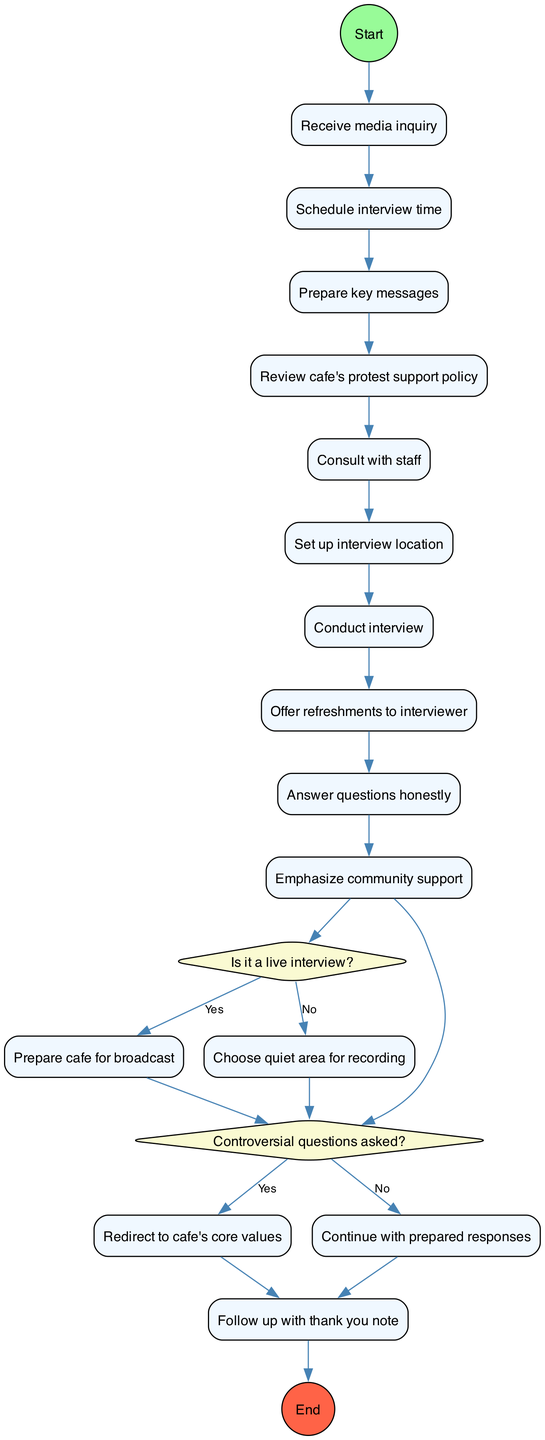What is the start node of the activity diagram? The start node is labeled with "Start" and is the initiating point of the flow in the diagram. It connects to the first activity, which is "Receive media inquiry."
Answer: Start How many activities are there in the diagram? There are a total of 9 activities listed in the diagram, starting from "Schedule interview time" to "Emphasize community support."
Answer: 9 What is the first activity after receiving a media inquiry? The first activity that follows the "Receive media inquiry" node is "Schedule interview time," indicating the first step in the process.
Answer: Schedule interview time What action is taken if the interview is live? If the interview is live, the next action is to "Prepare cafe for broadcast," which suggests adjustments to accommodate a live setting.
Answer: Prepare cafe for broadcast What happens if controversial questions are asked during the interview? When controversial questions are asked, the flow redirects to "Redirect to cafe's core values," ensuring the focus remains on the cafe's mission and values.
Answer: Redirect to cafe's core values How does the diagram end? The diagram concludes with a node labeled "Follow up with thank you note," which signifies the closure of the inquiry handling process.
Answer: Follow up with thank you note What decision follows the last activity? The last activity leads to a decision node regarding whether controversial questions are asked or not, which influences the direction of the flow.
Answer: Whether controversial questions are asked Is there a node dedicated to offering refreshments? Yes, there is an activity that specifically mentions "Offer refreshments to interviewer," highlighting the cafe's hospitality during interviews.
Answer: Offer refreshments to interviewer 